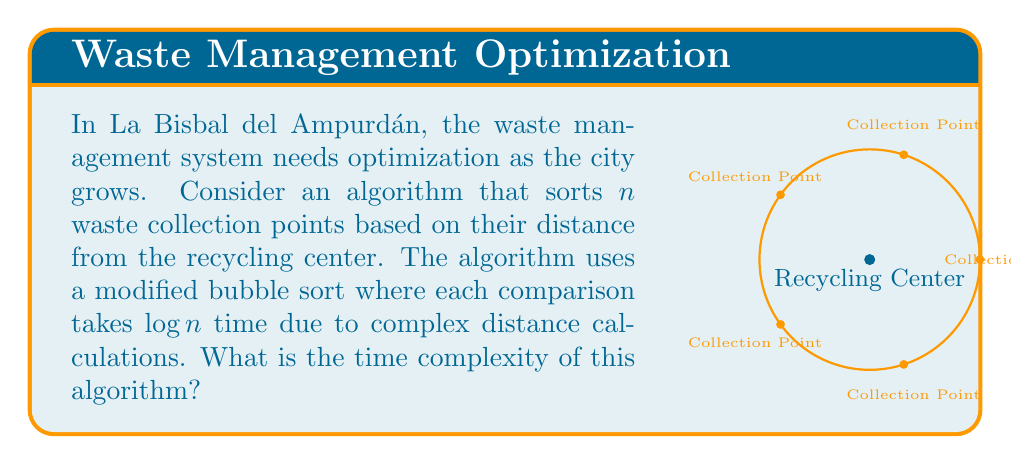Provide a solution to this math problem. Let's analyze this step-by-step:

1) In a standard bubble sort, we have:
   - $n-1$ passes through the list
   - In each pass, we perform up to $n-1$ comparisons

2) The total number of comparisons in a standard bubble sort is:

   $$(n-1) + (n-2) + ... + 2 + 1 = \frac{n(n-1)}{2}$$

3) In our modified algorithm, each comparison takes $\log n$ time. So we multiply the number of comparisons by $\log n$:

   $$\frac{n(n-1)}{2} \cdot \log n$$

4) Simplifying this expression:

   $$\frac{n^2 \log n - n \log n}{2}$$

5) In big O notation, we drop lower-order terms and constants. Therefore, the time complexity is:

   $$O(n^2 \log n)$$

This is worse than the standard bubble sort ($O(n^2)$) due to the added complexity of each comparison.
Answer: $O(n^2 \log n)$ 